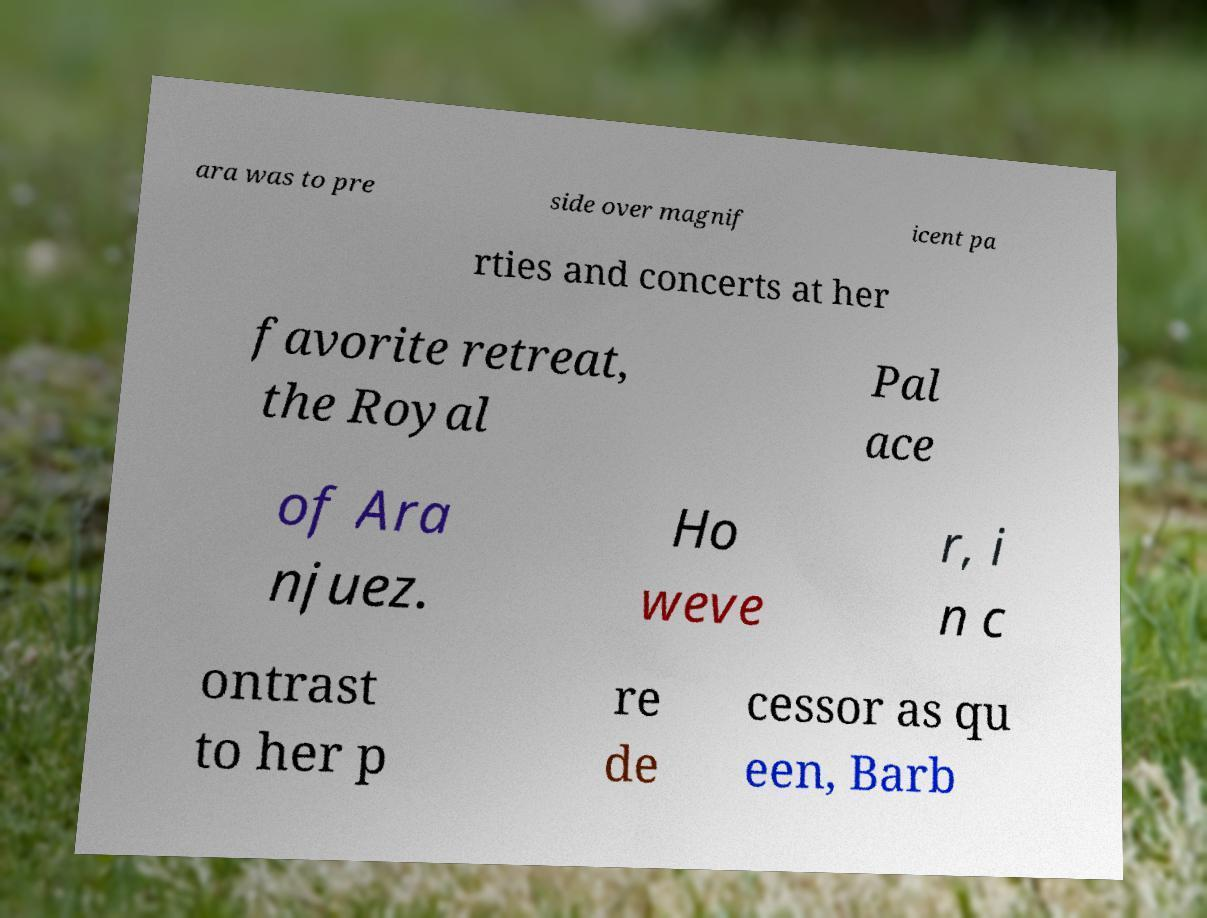What messages or text are displayed in this image? I need them in a readable, typed format. ara was to pre side over magnif icent pa rties and concerts at her favorite retreat, the Royal Pal ace of Ara njuez. Ho weve r, i n c ontrast to her p re de cessor as qu een, Barb 